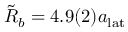Convert formula to latex. <formula><loc_0><loc_0><loc_500><loc_500>\tilde { R } _ { b } = 4 . 9 ( 2 ) a _ { l a t }</formula> 